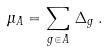<formula> <loc_0><loc_0><loc_500><loc_500>\mu _ { A } = \sum _ { g \in A } \, \Delta _ { g } \, .</formula> 